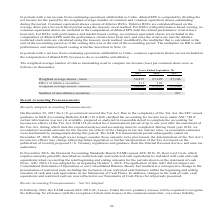According to Cubic's financial document, How is basic net income (loss) per share (EPS) computed? Based on the financial document, the answer is by dividing the net income (loss) attributable to Cubic for the period by the weighted average number of common shares outstanding during the period, including vested RSUs. Also, How are dilutive RSUs calculated? based on the average share price for each fiscal period using the treasury stock method. The document states: "st of dilutive RSUs. Dilutive RSUs are calculated based on the average share price for each fiscal period using the treasury stock method. For RSUs wi..." Also, For which years was the weighted-average number of shares outstanding used to compute net income (loss) per common share recorded? The document contains multiple relevant values: 2019, 2018, 2017. From the document: "Years Ended September 30, 2019 2018 2017 Years Ended September 30, 2019 2018 2017 Years Ended September 30, 2019 2018 2017..." Additionally, Which year has the largest amount for the effect of dilutive securities? According to the financial document, 2018. The relevant text states: "Years Ended September 30, 2019 2018 2017..." Also, can you calculate: What is the change in weighted average shares - basic in 2019 from 2018? Based on the calculation: 30,495-27,229, the result is 3266 (in thousands). This is based on the information: "Weighted average shares - basic 30,495 27,229 27,106 Effect of dilutive securities 111 122 — Weighted average shares - basic 30,495 27,229 27,106 Effect of dilutive securities 111 122 —..." The key data points involved are: 27,229, 30,495. Also, can you calculate: What is the percentage change in weighted average shares - basic in 2019 from 2018? To answer this question, I need to perform calculations using the financial data. The calculation is: (30,495-27,229)/27,229, which equals 11.99 (percentage). This is based on the information: "Weighted average shares - basic 30,495 27,229 27,106 Effect of dilutive securities 111 122 — Weighted average shares - basic 30,495 27,229 27,106 Effect of dilutive securities 111 122 —..." The key data points involved are: 27,229, 30,495. 